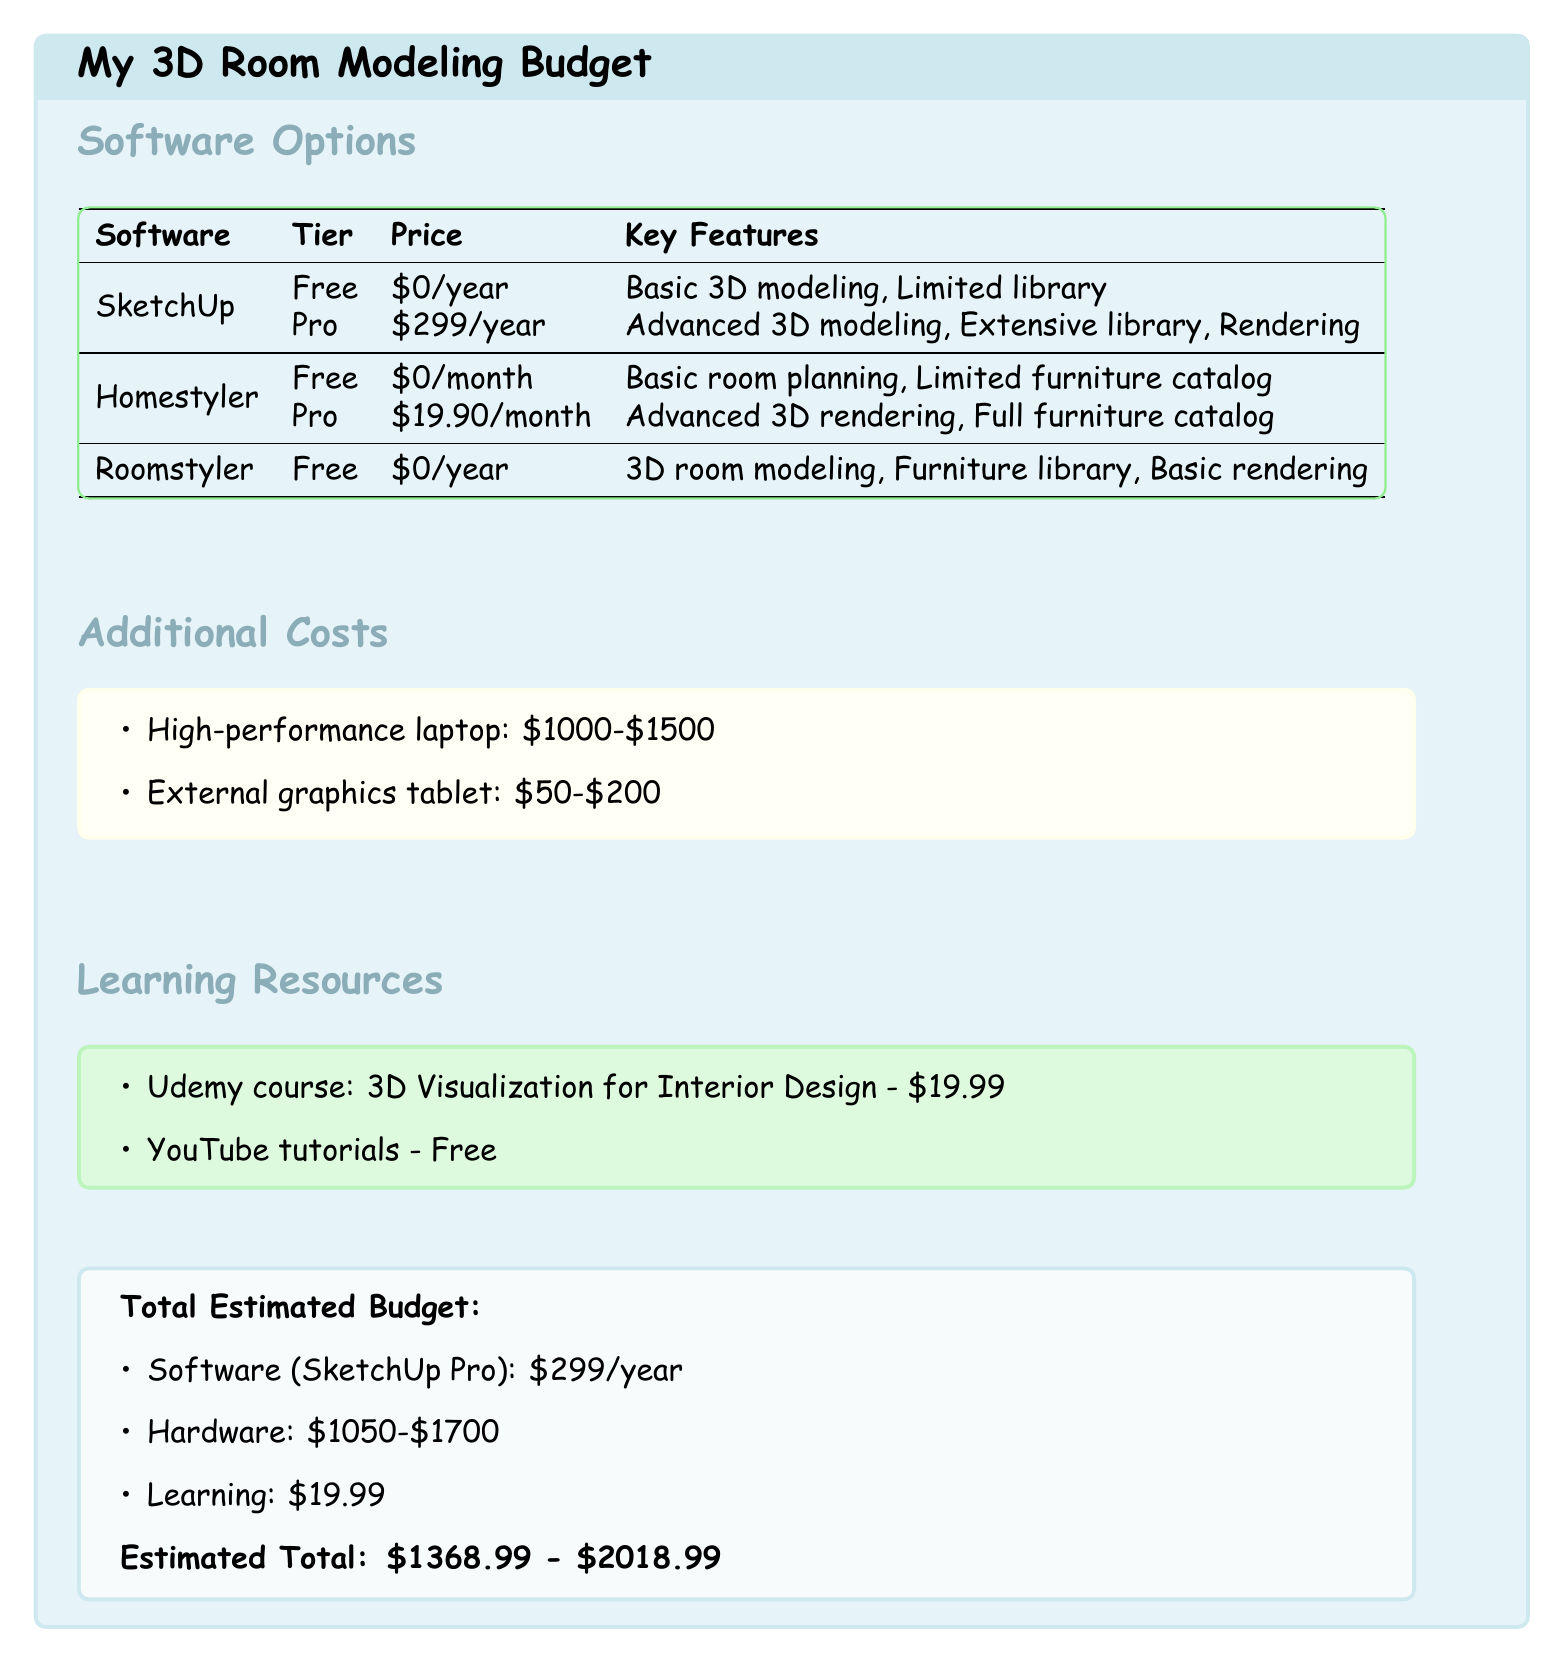what is the price of SketchUp Pro? The price of SketchUp Pro is listed in the document under the Software Options section, and it is \$299/year.
Answer: \$299/year what are the additional costs for a high-performance laptop? The document specifies a price range for a high-performance laptop under the Additional Costs section, which is \$1000 to \$1500.
Answer: \$1000-\$1500 how much does the Homestyler Pro cost per month? The cost for the Pro tier of Homestyler is provided in the Software Options section as \$19.90/month.
Answer: \$19.90/month what is the total estimated budget range? The total estimated budget is calculated based on various components in the document, leading to a range of \$1368.99 to \$2018.99.
Answer: \$1368.99 - \$2018.99 what learning resource is the cheapest option? The Learning Resources section lists various options, with YouTube tutorials being free, making it the cheapest option.
Answer: Free which software has an extensive library of models? Under the Software Options section, SketchUp Pro is indicated to have an extensive library as one of its key features.
Answer: SketchUp Pro how much does the Udemy course cost? The document lists the Udemy course price under Learning Resources, which is \$19.99.
Answer: \$19.99 what is the overall purpose of this document? The document is designed to present a budget for 3D room modeling software options, including costs and additional expenses.
Answer: Budget for 3D room modeling software 